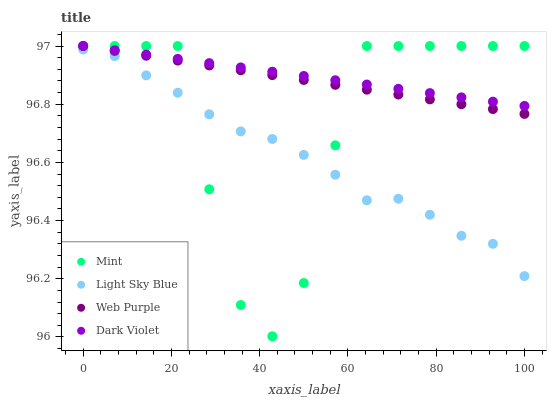Does Light Sky Blue have the minimum area under the curve?
Answer yes or no. Yes. Does Dark Violet have the maximum area under the curve?
Answer yes or no. Yes. Does Mint have the minimum area under the curve?
Answer yes or no. No. Does Mint have the maximum area under the curve?
Answer yes or no. No. Is Dark Violet the smoothest?
Answer yes or no. Yes. Is Mint the roughest?
Answer yes or no. Yes. Is Light Sky Blue the smoothest?
Answer yes or no. No. Is Light Sky Blue the roughest?
Answer yes or no. No. Does Mint have the lowest value?
Answer yes or no. Yes. Does Light Sky Blue have the lowest value?
Answer yes or no. No. Does Dark Violet have the highest value?
Answer yes or no. Yes. Does Light Sky Blue have the highest value?
Answer yes or no. No. Is Light Sky Blue less than Dark Violet?
Answer yes or no. Yes. Is Dark Violet greater than Light Sky Blue?
Answer yes or no. Yes. Does Mint intersect Web Purple?
Answer yes or no. Yes. Is Mint less than Web Purple?
Answer yes or no. No. Is Mint greater than Web Purple?
Answer yes or no. No. Does Light Sky Blue intersect Dark Violet?
Answer yes or no. No. 